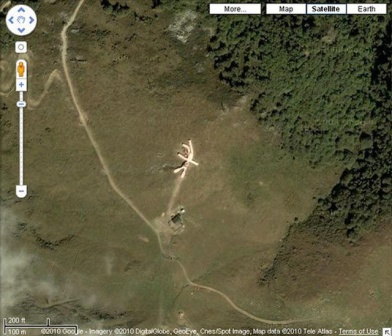If this site were part of a mystery novel, what role could it play? In a mystery novel, this site could serve as the pivotal setting for a climactic revelation. The X-shaped structure might be a secret meeting point for clandestine activities, involving covert operations or hidden treasures. It could be the location where the protagonist stumbles upon crucial evidence that unravels the mystery's enigma, such as a hidden underground lab or a cache of significant documents. The isolated and enigmatic nature of the site makes it a perfect backdrop for scenarios filled with suspense, secrets, and thrilling discoveries. 